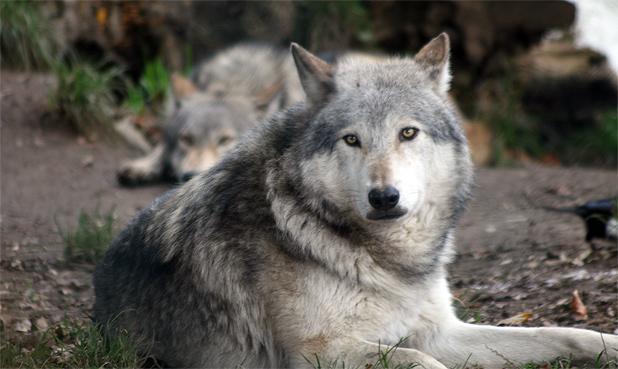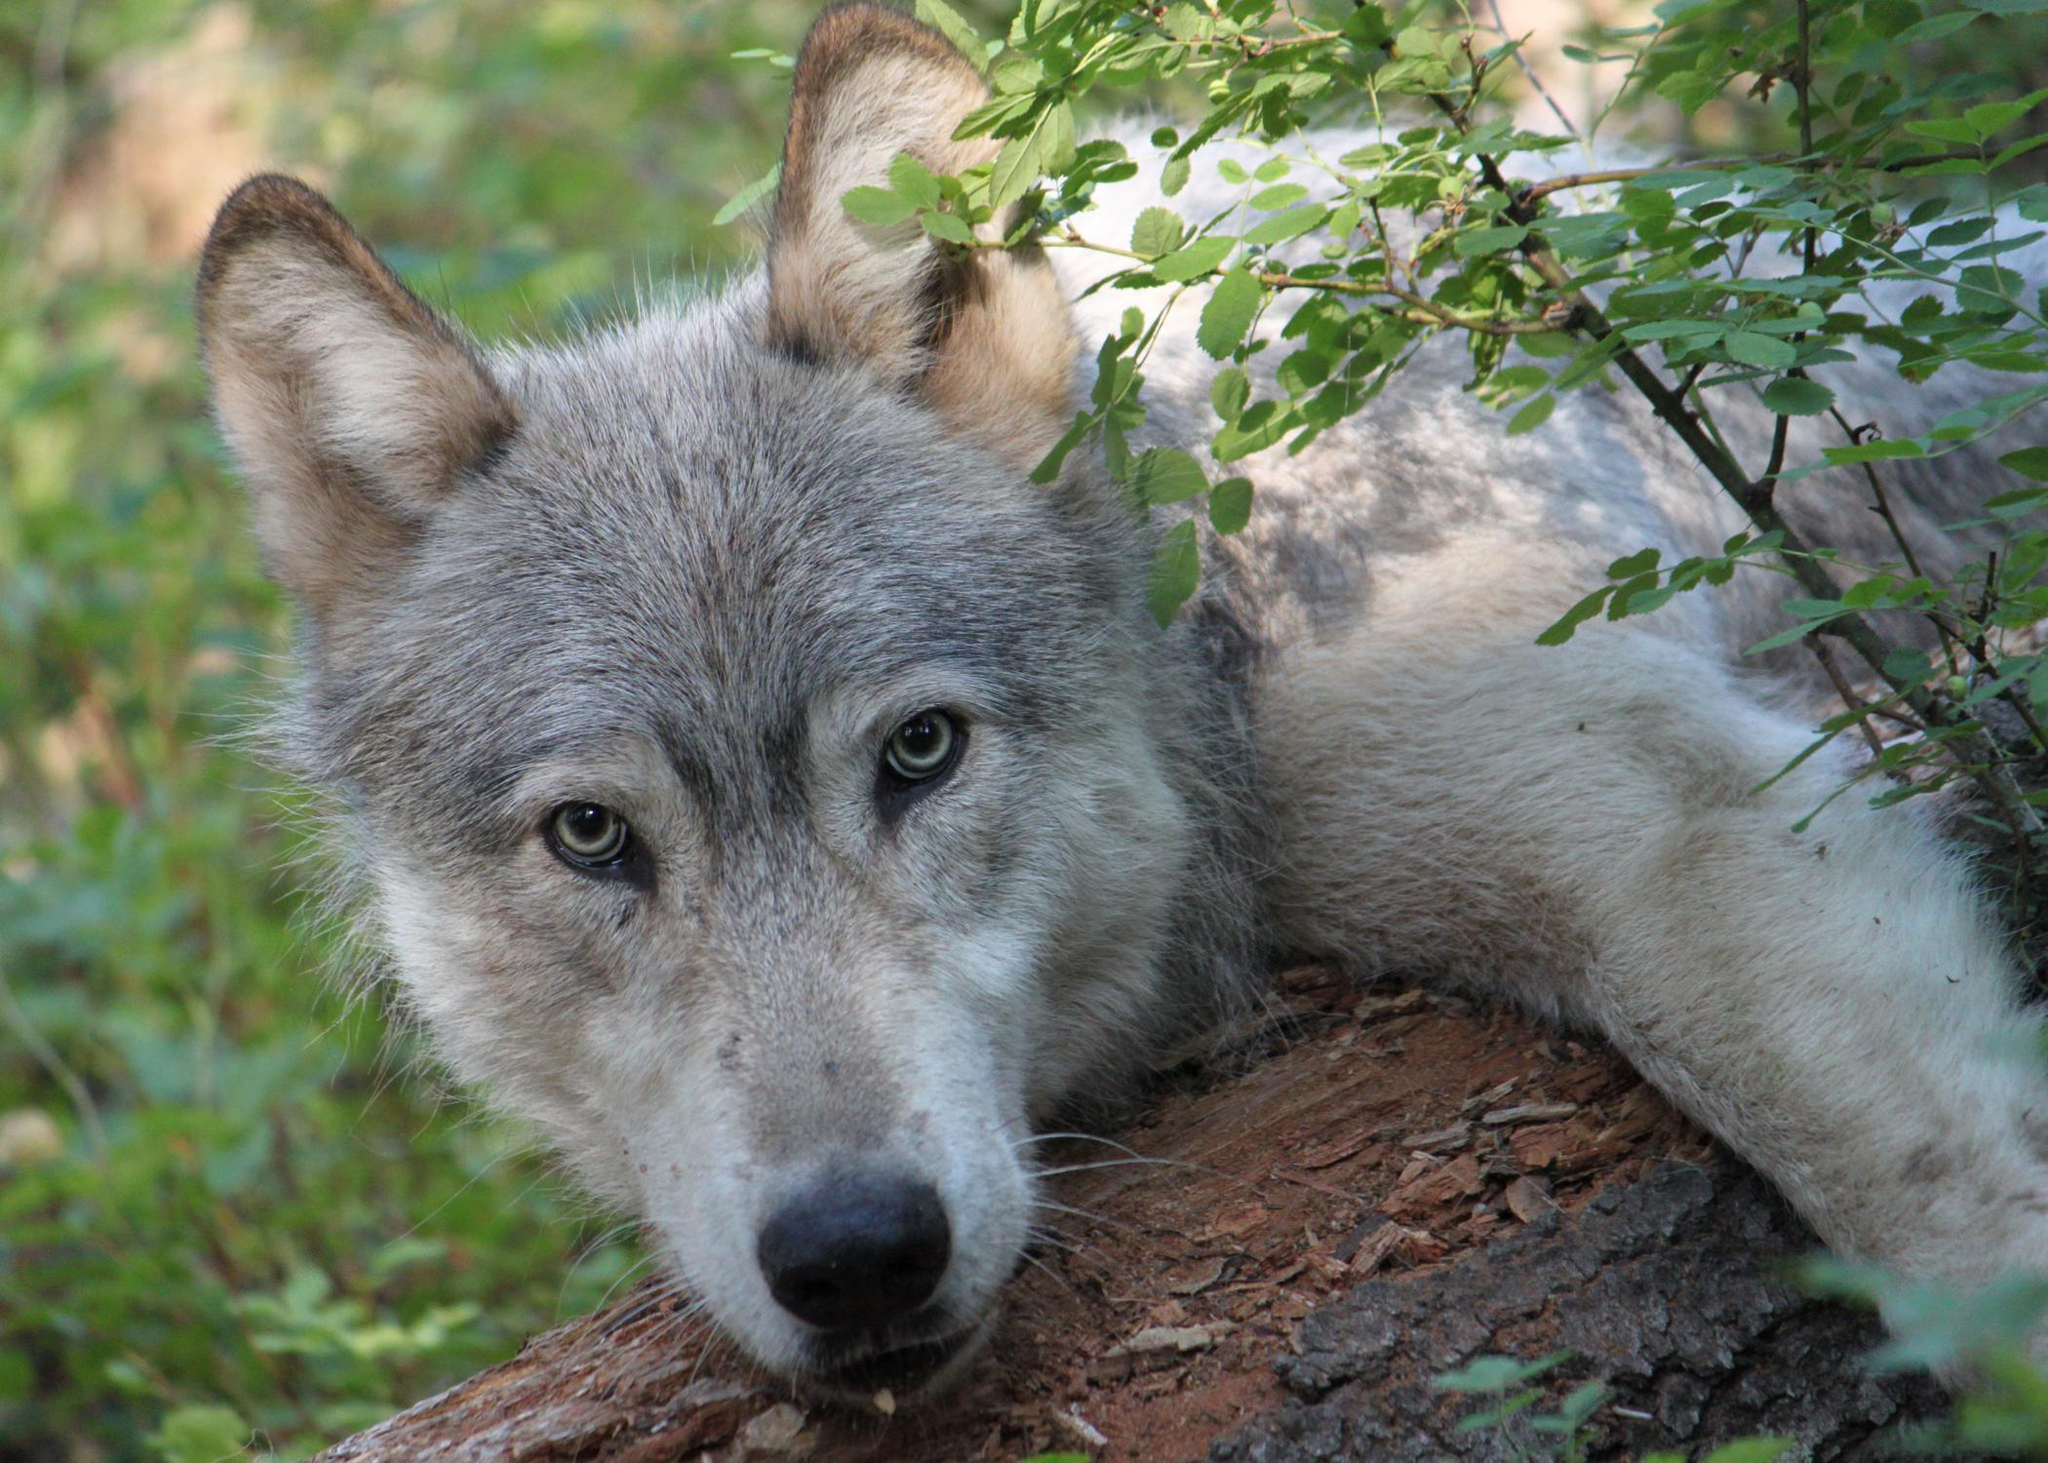The first image is the image on the left, the second image is the image on the right. Evaluate the accuracy of this statement regarding the images: "There are exactly four wolves in total.". Is it true? Answer yes or no. No. The first image is the image on the left, the second image is the image on the right. For the images displayed, is the sentence "The left image shows exactly two wolves, at least one with its mouth open and at least one with its eyes shut." factually correct? Answer yes or no. No. 